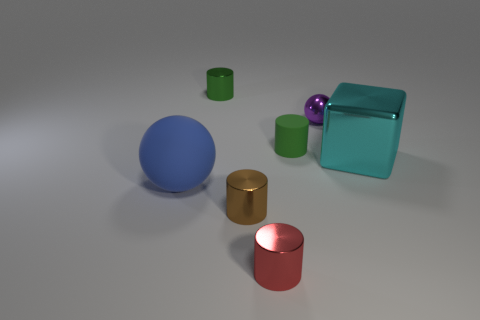Can you tell me which object stands out the most? The transparent teal cube stands out the most due to its larger size, unique transparency, and the way it reflects and refracts light differently compared to the other solid, opaque objects. 